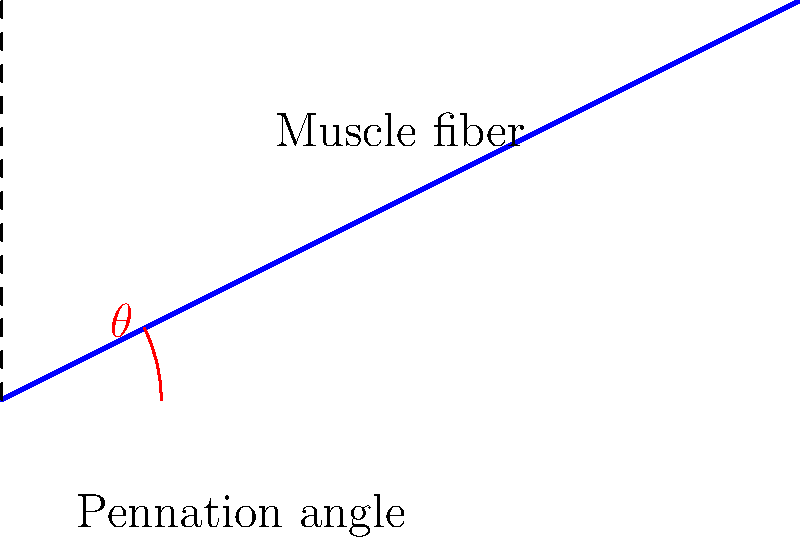In the given muscle architecture schematic, a muscle fiber is oriented at an angle $\theta$ (pennation angle) with respect to the vertical axis. If the length of the muscle fiber is 10 cm and its vertical projection is 8.94 cm, calculate the pennation angle $\theta$ in degrees. To solve this problem, we'll use trigonometry:

1) Let's define our known values:
   - Muscle fiber length = 10 cm
   - Vertical projection = 8.94 cm

2) The vertical projection represents the adjacent side of the right triangle formed by the muscle fiber and the vertical axis, while the muscle fiber length represents the hypotenuse.

3) We can use the cosine function to find the angle:

   $$\cos(\theta) = \frac{\text{adjacent}}{\text{hypotenuse}} = \frac{\text{vertical projection}}{\text{muscle fiber length}}$$

4) Substituting our values:

   $$\cos(\theta) = \frac{8.94}{10} = 0.894$$

5) To find $\theta$, we need to take the inverse cosine (arccos) of both sides:

   $$\theta = \arccos(0.894)$$

6) Using a calculator or computer:

   $$\theta \approx 26.57°$$

Therefore, the pennation angle is approximately 26.57 degrees.
Answer: 26.57° 